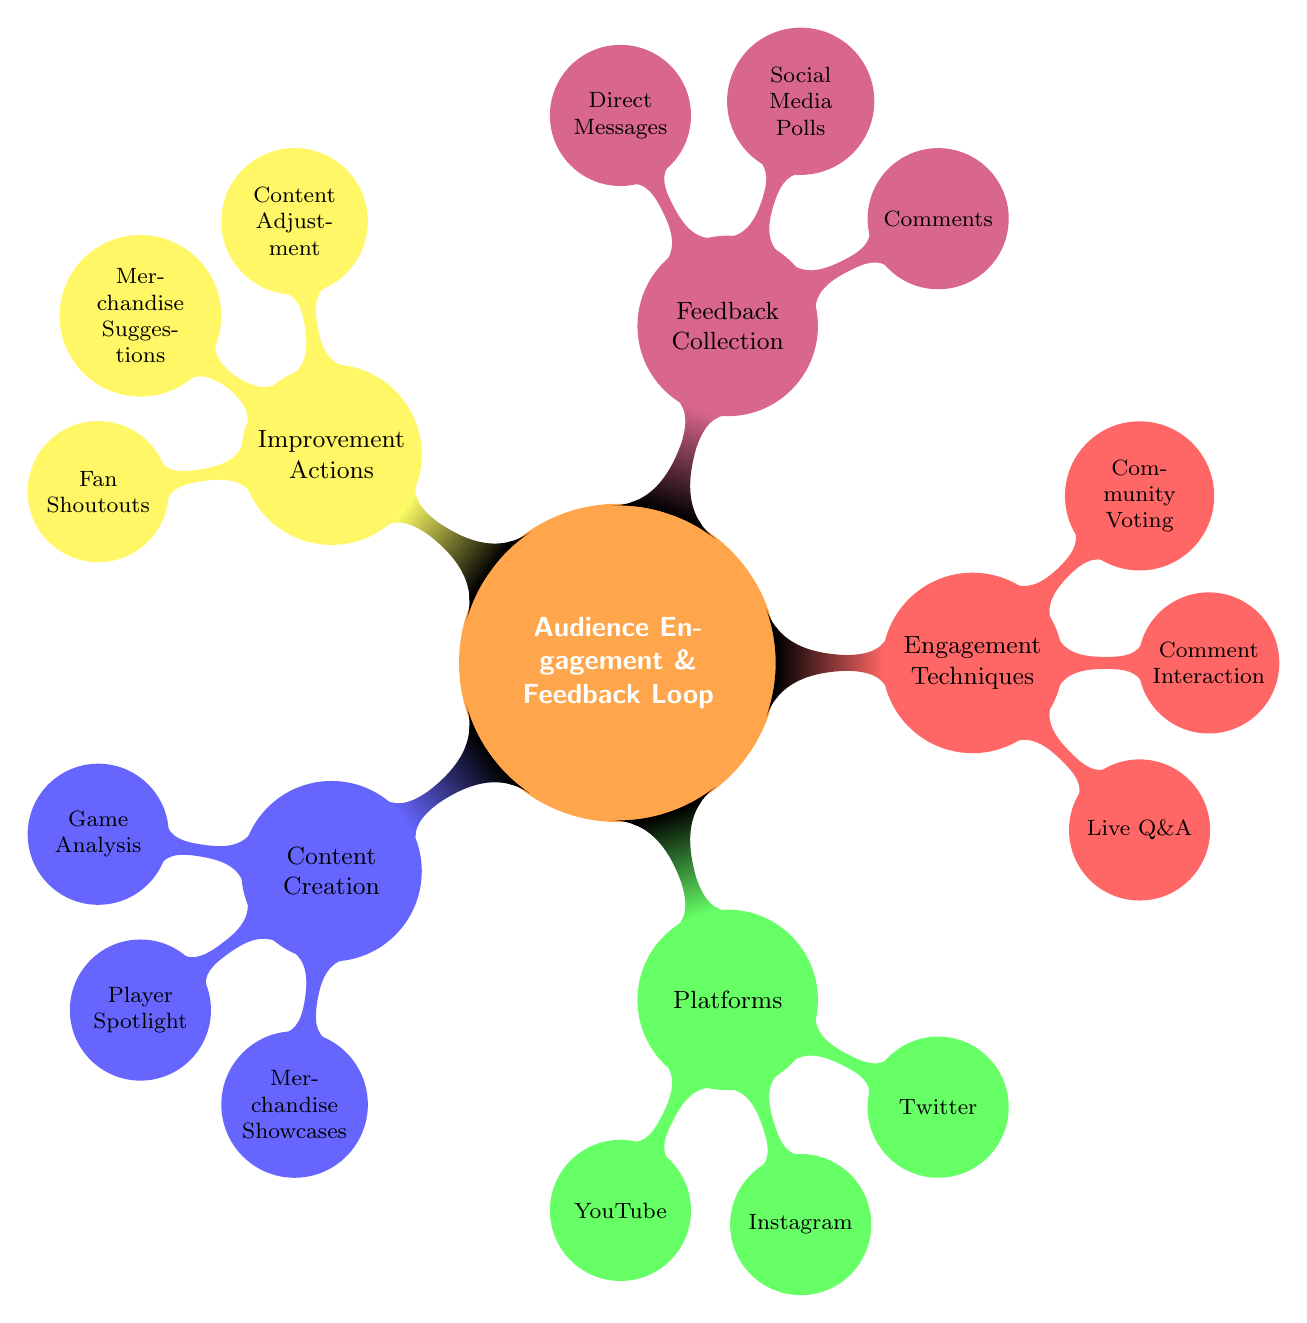What are the three main categories in the mind map? The mind map has five main categories: Content Creation, Platforms, Engagement Techniques, Feedback Collection, and Improvement Actions.
Answer: Content Creation, Platforms, Engagement Techniques, Feedback Collection, Improvement Actions How many engagement techniques are listed? In the Engagement Techniques category, there are three techniques listed: Live Q&A Sessions, Comment Interaction, and Community Voting. This can be counted directly from the diagram.
Answer: Three Which platform is associated with merchandise showcases? Merchandise Showcases fall under the Content Creation category, but none of the platforms specifically mention merchandising. However, YouTube is likely the primary platform for showcasing merchandise via videos.
Answer: YouTube What is one method for feedback collection? The Feedback Collection category includes three methods: Comments Section, Social Media Polls, and Direct Messages. Any of these would be a valid answer.
Answer: Comments Section Which engagement technique is related to real-time interaction? The engagement technique that involves real-time interaction is Live Q&A Sessions. This can be inferred from the nature of the interaction offered.
Answer: Live Q&A Sessions How many nodes are connected to the 'Platforms' category? The Platforms category has three nodes connected to it: YouTube Channel, Instagram Stories, and Twitter Polls. These can be identified by counting the subcategories listed under Platforms.
Answer: Three What is the purpose of the Improvement Actions category? Improvement Actions is focused on actions taken to enhance content based on feedback. These actions are directly derived from listeners and involve modifications.
Answer: Enhance content Which category contains suggestions related to merchandise? The Improvement Actions category contains Merchandise Suggestions. This can be seen as directly stated under the respective category.
Answer: Merchandise Suggestions What method is indicated for interactive audience participation? The method for interactive audience participation is Community Voting, which allows audience members to express their preferences.
Answer: Community Voting 